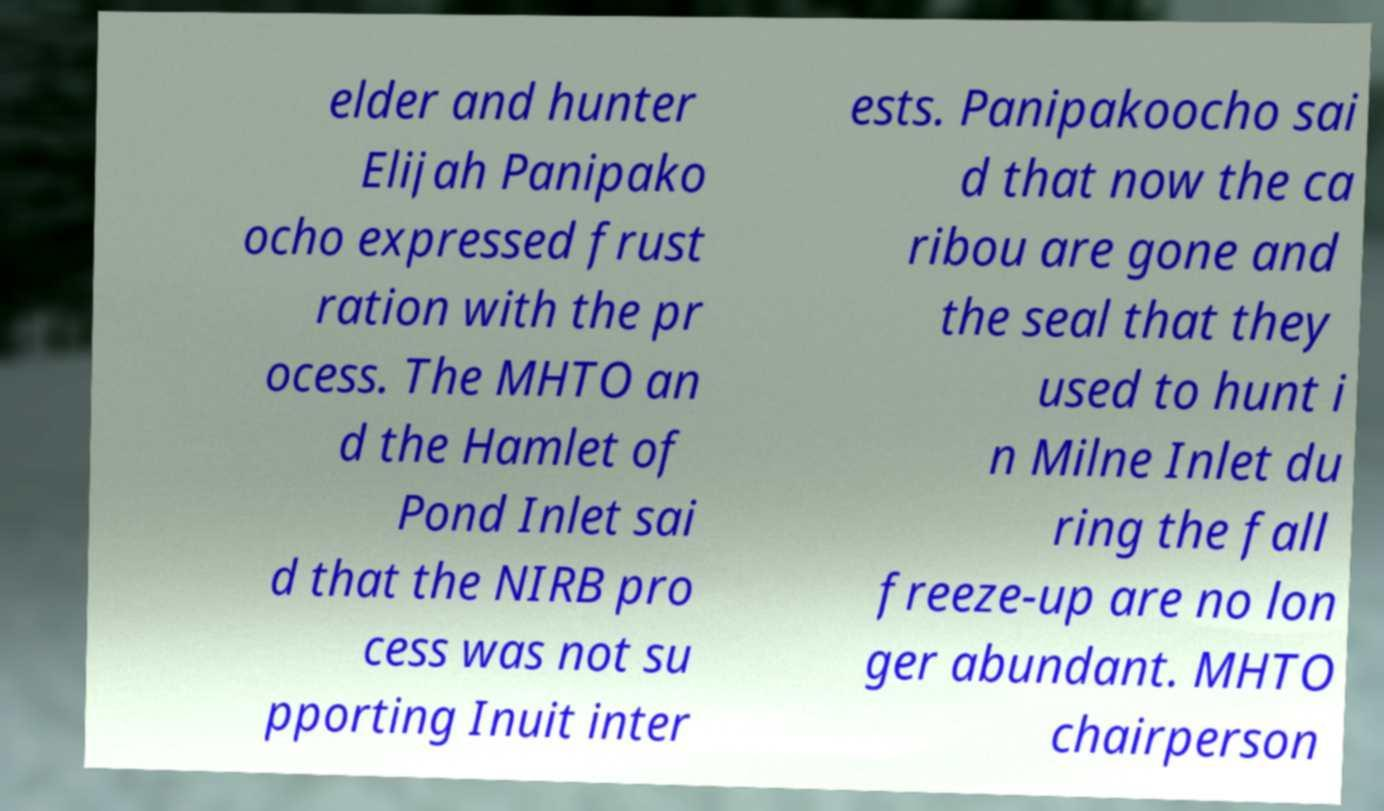Could you extract and type out the text from this image? elder and hunter Elijah Panipako ocho expressed frust ration with the pr ocess. The MHTO an d the Hamlet of Pond Inlet sai d that the NIRB pro cess was not su pporting Inuit inter ests. Panipakoocho sai d that now the ca ribou are gone and the seal that they used to hunt i n Milne Inlet du ring the fall freeze-up are no lon ger abundant. MHTO chairperson 